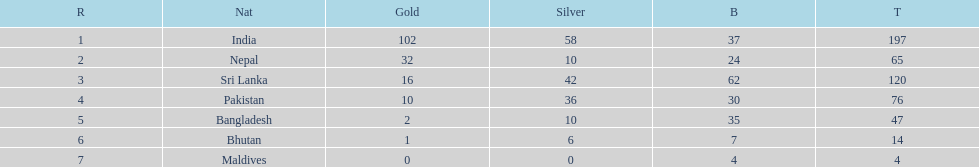How many more gold medals has nepal won than pakistan? 22. 